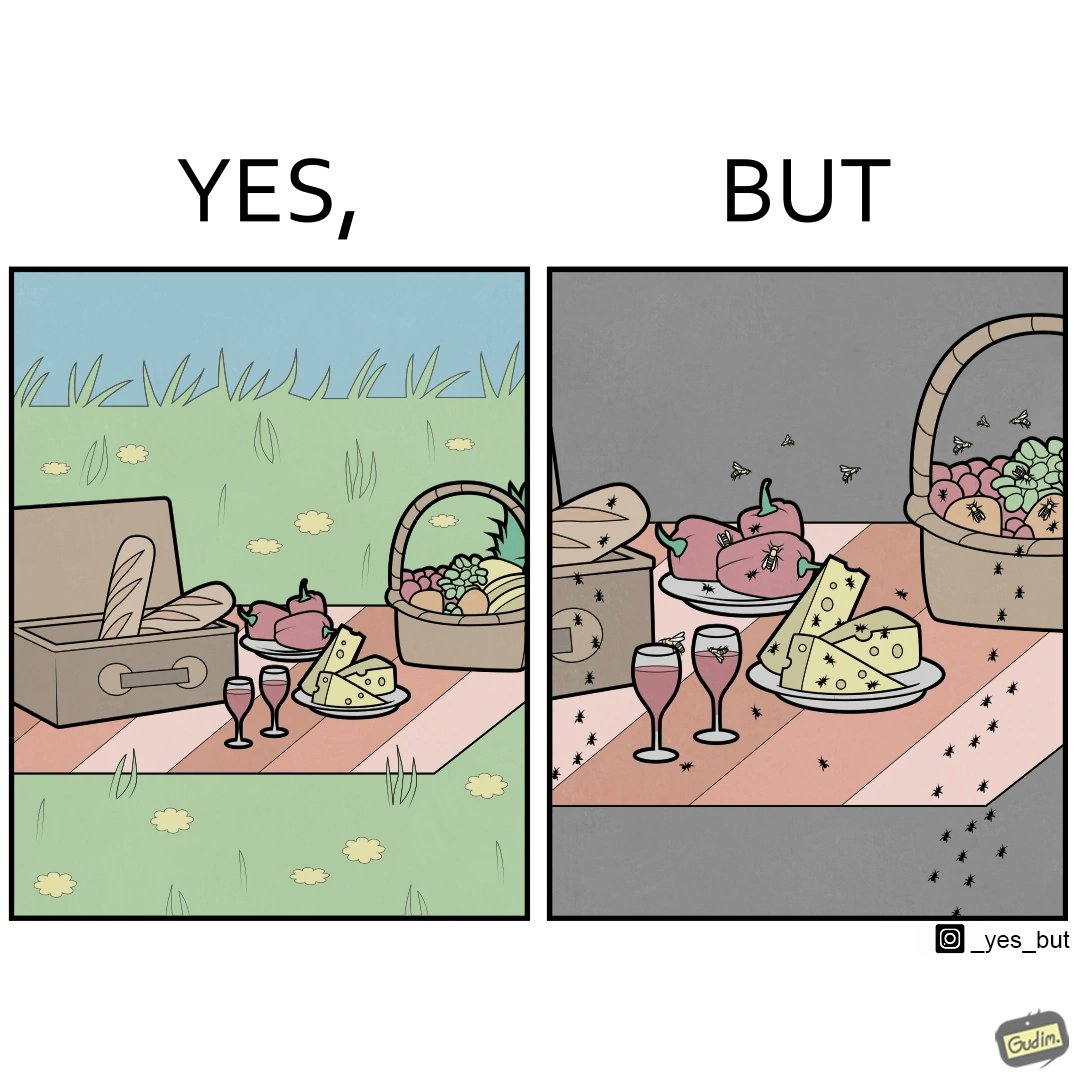What is shown in the left half versus the right half of this image? In the left part of the image: The food is kept on a blanket in a garden. In the right part of the image: Some bugs are attracting towards the food. 